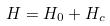Convert formula to latex. <formula><loc_0><loc_0><loc_500><loc_500>H = H _ { 0 } + H _ { c }</formula> 